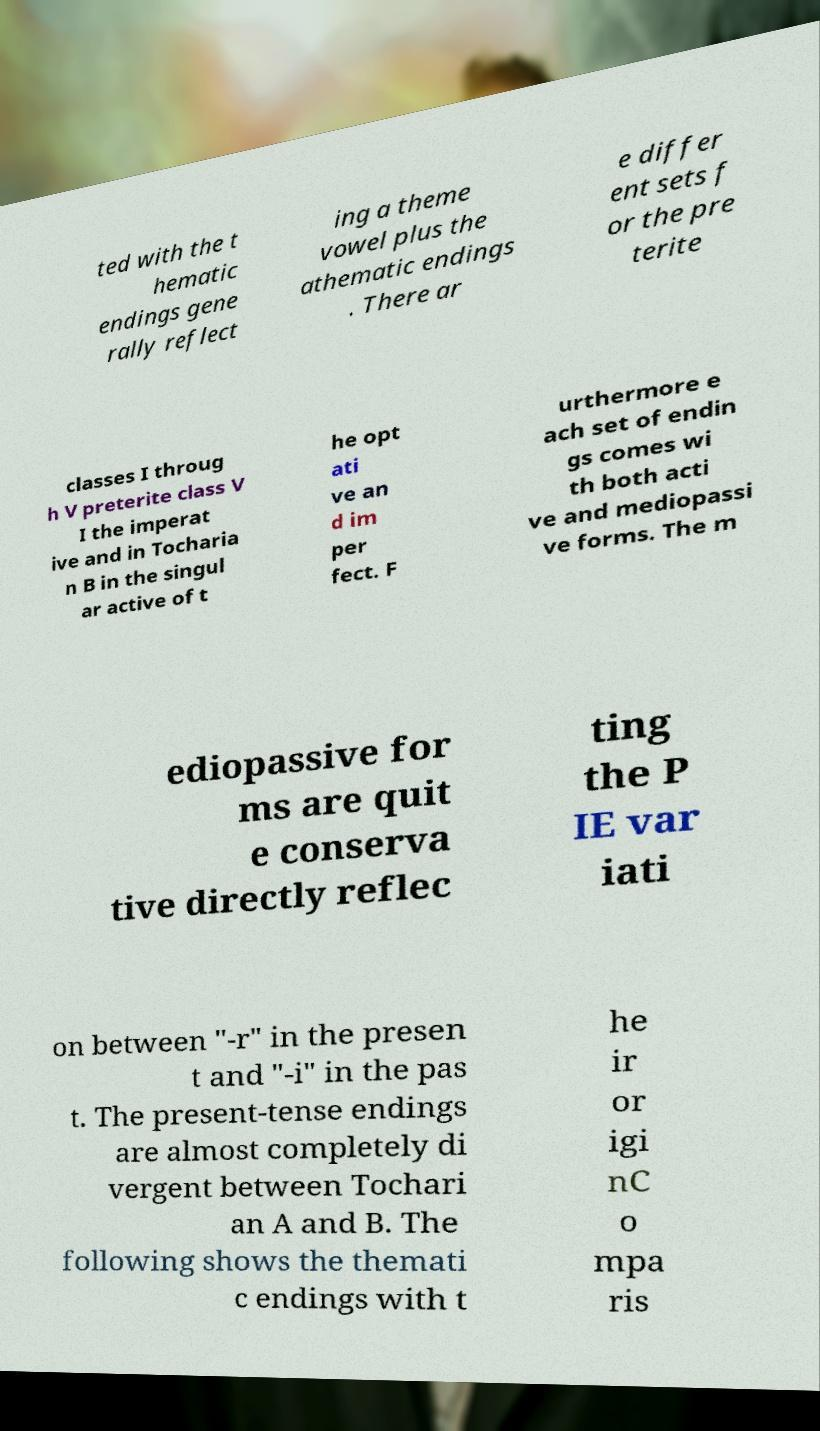I need the written content from this picture converted into text. Can you do that? ted with the t hematic endings gene rally reflect ing a theme vowel plus the athematic endings . There ar e differ ent sets f or the pre terite classes I throug h V preterite class V I the imperat ive and in Tocharia n B in the singul ar active of t he opt ati ve an d im per fect. F urthermore e ach set of endin gs comes wi th both acti ve and mediopassi ve forms. The m ediopassive for ms are quit e conserva tive directly reflec ting the P IE var iati on between "-r" in the presen t and "-i" in the pas t. The present-tense endings are almost completely di vergent between Tochari an A and B. The following shows the themati c endings with t he ir or igi nC o mpa ris 